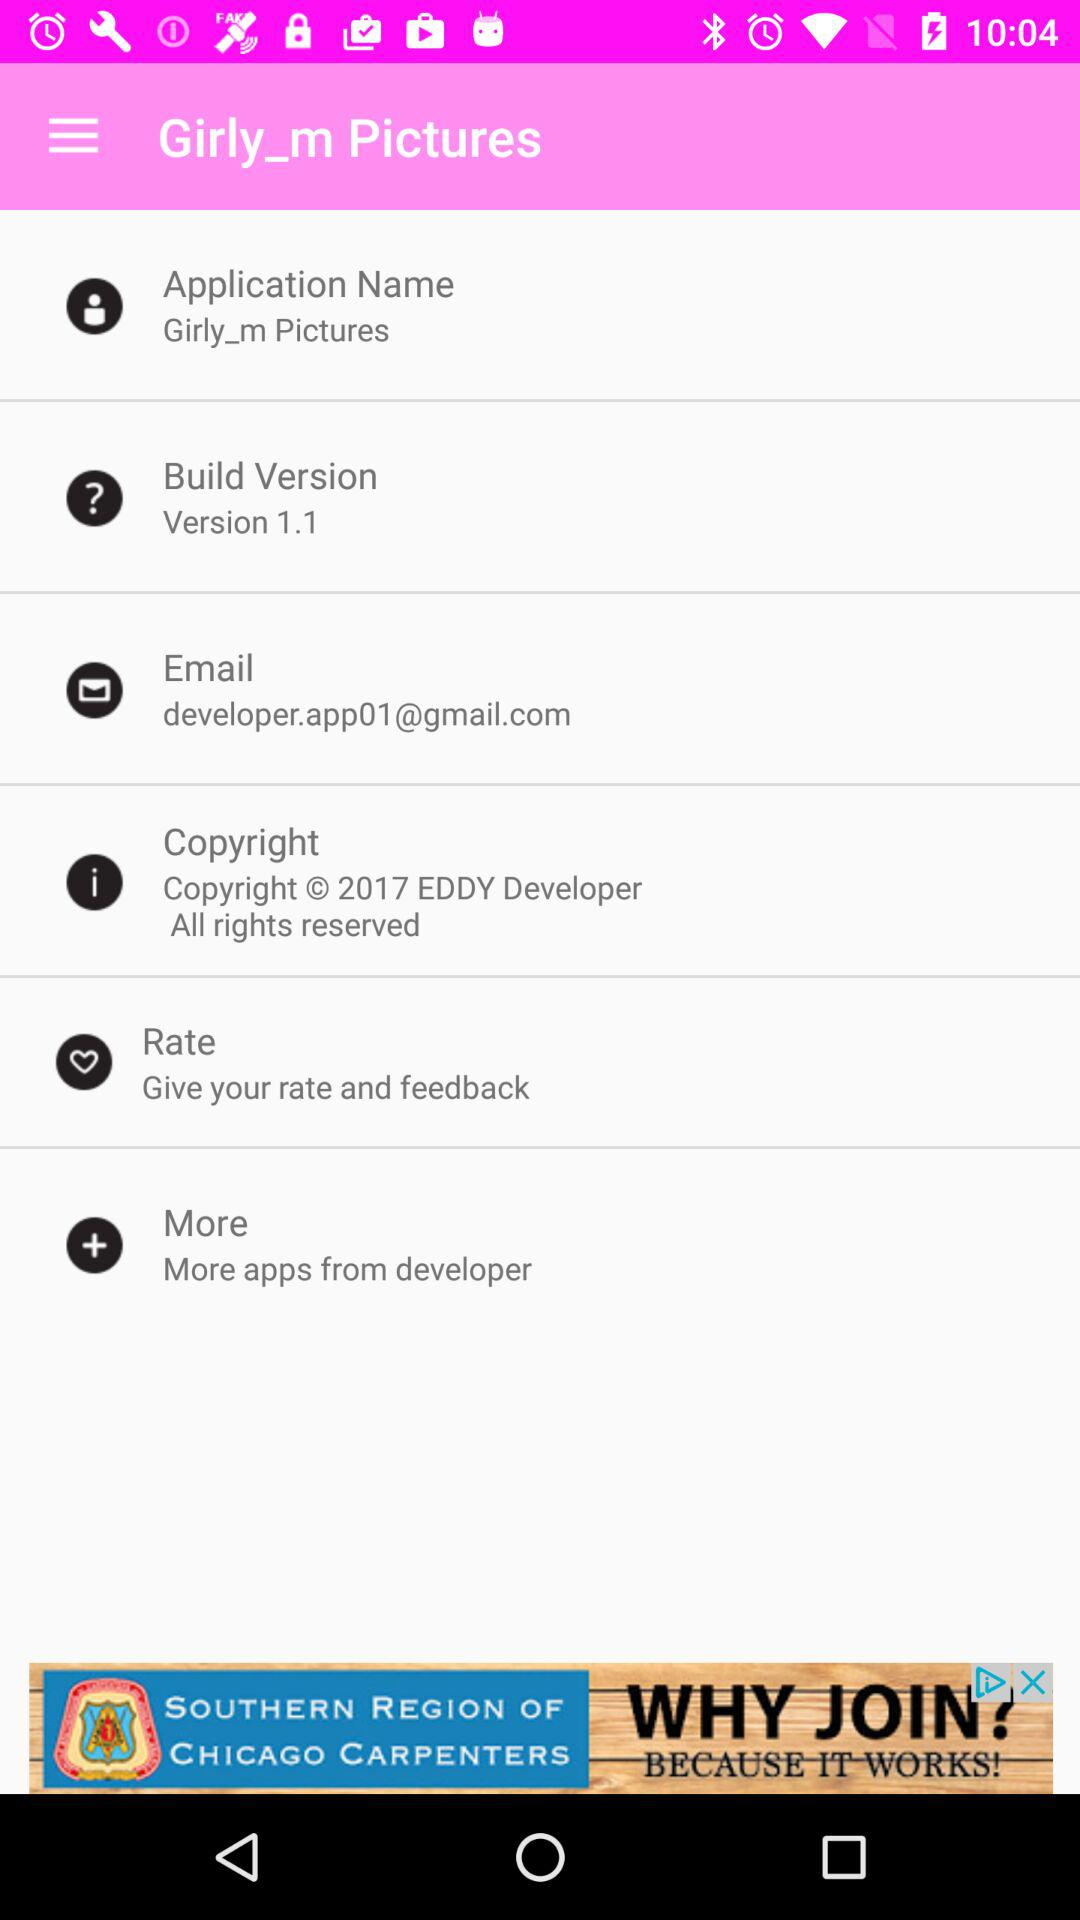What is the build version of the application? The build version of the application is 1.1. 